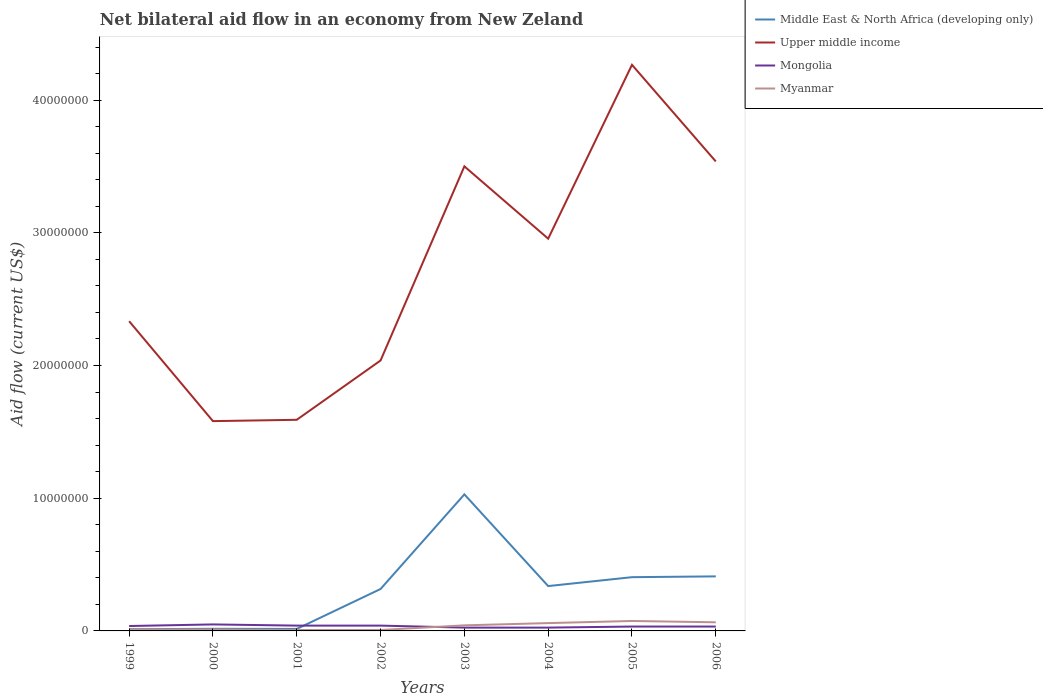How many different coloured lines are there?
Give a very brief answer. 4. Does the line corresponding to Myanmar intersect with the line corresponding to Middle East & North Africa (developing only)?
Keep it short and to the point. No. Across all years, what is the maximum net bilateral aid flow in Middle East & North Africa (developing only)?
Make the answer very short. 1.30e+05. In which year was the net bilateral aid flow in Myanmar maximum?
Give a very brief answer. 2001. What is the total net bilateral aid flow in Upper middle income in the graph?
Offer a very short reply. -4.57e+06. What is the difference between the highest and the second highest net bilateral aid flow in Upper middle income?
Your answer should be compact. 2.68e+07. Is the net bilateral aid flow in Upper middle income strictly greater than the net bilateral aid flow in Middle East & North Africa (developing only) over the years?
Ensure brevity in your answer.  No. How many lines are there?
Offer a terse response. 4. What is the difference between two consecutive major ticks on the Y-axis?
Your answer should be very brief. 1.00e+07. Are the values on the major ticks of Y-axis written in scientific E-notation?
Offer a very short reply. No. Does the graph contain any zero values?
Your answer should be very brief. No. Where does the legend appear in the graph?
Provide a short and direct response. Top right. How many legend labels are there?
Provide a short and direct response. 4. How are the legend labels stacked?
Provide a succinct answer. Vertical. What is the title of the graph?
Your answer should be very brief. Net bilateral aid flow in an economy from New Zeland. Does "Saudi Arabia" appear as one of the legend labels in the graph?
Your answer should be very brief. No. What is the label or title of the X-axis?
Make the answer very short. Years. What is the Aid flow (current US$) in Upper middle income in 1999?
Your answer should be very brief. 2.33e+07. What is the Aid flow (current US$) in Myanmar in 1999?
Your answer should be compact. 1.10e+05. What is the Aid flow (current US$) in Middle East & North Africa (developing only) in 2000?
Keep it short and to the point. 1.60e+05. What is the Aid flow (current US$) in Upper middle income in 2000?
Your answer should be very brief. 1.58e+07. What is the Aid flow (current US$) of Middle East & North Africa (developing only) in 2001?
Make the answer very short. 1.50e+05. What is the Aid flow (current US$) in Upper middle income in 2001?
Provide a succinct answer. 1.59e+07. What is the Aid flow (current US$) of Myanmar in 2001?
Your answer should be compact. 7.00e+04. What is the Aid flow (current US$) of Middle East & North Africa (developing only) in 2002?
Make the answer very short. 3.16e+06. What is the Aid flow (current US$) in Upper middle income in 2002?
Give a very brief answer. 2.04e+07. What is the Aid flow (current US$) in Mongolia in 2002?
Your answer should be very brief. 4.00e+05. What is the Aid flow (current US$) of Middle East & North Africa (developing only) in 2003?
Offer a terse response. 1.03e+07. What is the Aid flow (current US$) in Upper middle income in 2003?
Offer a very short reply. 3.50e+07. What is the Aid flow (current US$) of Myanmar in 2003?
Provide a succinct answer. 4.20e+05. What is the Aid flow (current US$) in Middle East & North Africa (developing only) in 2004?
Give a very brief answer. 3.38e+06. What is the Aid flow (current US$) of Upper middle income in 2004?
Offer a terse response. 2.96e+07. What is the Aid flow (current US$) of Mongolia in 2004?
Make the answer very short. 2.50e+05. What is the Aid flow (current US$) in Myanmar in 2004?
Give a very brief answer. 5.90e+05. What is the Aid flow (current US$) in Middle East & North Africa (developing only) in 2005?
Offer a terse response. 4.05e+06. What is the Aid flow (current US$) of Upper middle income in 2005?
Keep it short and to the point. 4.27e+07. What is the Aid flow (current US$) of Myanmar in 2005?
Provide a succinct answer. 7.50e+05. What is the Aid flow (current US$) of Middle East & North Africa (developing only) in 2006?
Your answer should be compact. 4.11e+06. What is the Aid flow (current US$) of Upper middle income in 2006?
Your answer should be compact. 3.54e+07. What is the Aid flow (current US$) of Mongolia in 2006?
Keep it short and to the point. 3.30e+05. What is the Aid flow (current US$) of Myanmar in 2006?
Ensure brevity in your answer.  6.50e+05. Across all years, what is the maximum Aid flow (current US$) in Middle East & North Africa (developing only)?
Make the answer very short. 1.03e+07. Across all years, what is the maximum Aid flow (current US$) in Upper middle income?
Offer a very short reply. 4.27e+07. Across all years, what is the maximum Aid flow (current US$) in Mongolia?
Your answer should be compact. 4.90e+05. Across all years, what is the maximum Aid flow (current US$) of Myanmar?
Keep it short and to the point. 7.50e+05. Across all years, what is the minimum Aid flow (current US$) in Middle East & North Africa (developing only)?
Offer a terse response. 1.30e+05. Across all years, what is the minimum Aid flow (current US$) of Upper middle income?
Ensure brevity in your answer.  1.58e+07. Across all years, what is the minimum Aid flow (current US$) of Mongolia?
Ensure brevity in your answer.  2.50e+05. Across all years, what is the minimum Aid flow (current US$) in Myanmar?
Your response must be concise. 7.00e+04. What is the total Aid flow (current US$) of Middle East & North Africa (developing only) in the graph?
Give a very brief answer. 2.54e+07. What is the total Aid flow (current US$) in Upper middle income in the graph?
Provide a succinct answer. 2.18e+08. What is the total Aid flow (current US$) of Mongolia in the graph?
Offer a terse response. 2.82e+06. What is the total Aid flow (current US$) of Myanmar in the graph?
Your response must be concise. 2.76e+06. What is the difference between the Aid flow (current US$) in Upper middle income in 1999 and that in 2000?
Give a very brief answer. 7.53e+06. What is the difference between the Aid flow (current US$) in Middle East & North Africa (developing only) in 1999 and that in 2001?
Ensure brevity in your answer.  -2.00e+04. What is the difference between the Aid flow (current US$) in Upper middle income in 1999 and that in 2001?
Keep it short and to the point. 7.43e+06. What is the difference between the Aid flow (current US$) of Mongolia in 1999 and that in 2001?
Give a very brief answer. -3.00e+04. What is the difference between the Aid flow (current US$) in Myanmar in 1999 and that in 2001?
Offer a terse response. 4.00e+04. What is the difference between the Aid flow (current US$) in Middle East & North Africa (developing only) in 1999 and that in 2002?
Your response must be concise. -3.03e+06. What is the difference between the Aid flow (current US$) of Upper middle income in 1999 and that in 2002?
Provide a succinct answer. 2.96e+06. What is the difference between the Aid flow (current US$) of Mongolia in 1999 and that in 2002?
Offer a very short reply. -3.00e+04. What is the difference between the Aid flow (current US$) in Myanmar in 1999 and that in 2002?
Give a very brief answer. 4.00e+04. What is the difference between the Aid flow (current US$) of Middle East & North Africa (developing only) in 1999 and that in 2003?
Give a very brief answer. -1.02e+07. What is the difference between the Aid flow (current US$) in Upper middle income in 1999 and that in 2003?
Ensure brevity in your answer.  -1.17e+07. What is the difference between the Aid flow (current US$) of Mongolia in 1999 and that in 2003?
Give a very brief answer. 1.20e+05. What is the difference between the Aid flow (current US$) in Myanmar in 1999 and that in 2003?
Your answer should be compact. -3.10e+05. What is the difference between the Aid flow (current US$) in Middle East & North Africa (developing only) in 1999 and that in 2004?
Give a very brief answer. -3.25e+06. What is the difference between the Aid flow (current US$) in Upper middle income in 1999 and that in 2004?
Provide a succinct answer. -6.22e+06. What is the difference between the Aid flow (current US$) in Mongolia in 1999 and that in 2004?
Your answer should be compact. 1.20e+05. What is the difference between the Aid flow (current US$) in Myanmar in 1999 and that in 2004?
Ensure brevity in your answer.  -4.80e+05. What is the difference between the Aid flow (current US$) in Middle East & North Africa (developing only) in 1999 and that in 2005?
Your response must be concise. -3.92e+06. What is the difference between the Aid flow (current US$) of Upper middle income in 1999 and that in 2005?
Your answer should be compact. -1.93e+07. What is the difference between the Aid flow (current US$) in Myanmar in 1999 and that in 2005?
Provide a succinct answer. -6.40e+05. What is the difference between the Aid flow (current US$) of Middle East & North Africa (developing only) in 1999 and that in 2006?
Keep it short and to the point. -3.98e+06. What is the difference between the Aid flow (current US$) of Upper middle income in 1999 and that in 2006?
Ensure brevity in your answer.  -1.20e+07. What is the difference between the Aid flow (current US$) in Mongolia in 1999 and that in 2006?
Offer a terse response. 4.00e+04. What is the difference between the Aid flow (current US$) in Myanmar in 1999 and that in 2006?
Keep it short and to the point. -5.40e+05. What is the difference between the Aid flow (current US$) in Middle East & North Africa (developing only) in 2000 and that in 2001?
Ensure brevity in your answer.  10000. What is the difference between the Aid flow (current US$) of Middle East & North Africa (developing only) in 2000 and that in 2002?
Offer a very short reply. -3.00e+06. What is the difference between the Aid flow (current US$) of Upper middle income in 2000 and that in 2002?
Your response must be concise. -4.57e+06. What is the difference between the Aid flow (current US$) in Mongolia in 2000 and that in 2002?
Provide a short and direct response. 9.00e+04. What is the difference between the Aid flow (current US$) in Myanmar in 2000 and that in 2002?
Give a very brief answer. 3.00e+04. What is the difference between the Aid flow (current US$) of Middle East & North Africa (developing only) in 2000 and that in 2003?
Give a very brief answer. -1.01e+07. What is the difference between the Aid flow (current US$) of Upper middle income in 2000 and that in 2003?
Provide a succinct answer. -1.92e+07. What is the difference between the Aid flow (current US$) in Myanmar in 2000 and that in 2003?
Offer a terse response. -3.20e+05. What is the difference between the Aid flow (current US$) of Middle East & North Africa (developing only) in 2000 and that in 2004?
Your answer should be compact. -3.22e+06. What is the difference between the Aid flow (current US$) in Upper middle income in 2000 and that in 2004?
Offer a terse response. -1.38e+07. What is the difference between the Aid flow (current US$) of Myanmar in 2000 and that in 2004?
Give a very brief answer. -4.90e+05. What is the difference between the Aid flow (current US$) of Middle East & North Africa (developing only) in 2000 and that in 2005?
Your answer should be very brief. -3.89e+06. What is the difference between the Aid flow (current US$) of Upper middle income in 2000 and that in 2005?
Keep it short and to the point. -2.68e+07. What is the difference between the Aid flow (current US$) of Mongolia in 2000 and that in 2005?
Offer a terse response. 1.60e+05. What is the difference between the Aid flow (current US$) of Myanmar in 2000 and that in 2005?
Ensure brevity in your answer.  -6.50e+05. What is the difference between the Aid flow (current US$) in Middle East & North Africa (developing only) in 2000 and that in 2006?
Make the answer very short. -3.95e+06. What is the difference between the Aid flow (current US$) in Upper middle income in 2000 and that in 2006?
Your answer should be very brief. -1.96e+07. What is the difference between the Aid flow (current US$) in Myanmar in 2000 and that in 2006?
Ensure brevity in your answer.  -5.50e+05. What is the difference between the Aid flow (current US$) of Middle East & North Africa (developing only) in 2001 and that in 2002?
Provide a short and direct response. -3.01e+06. What is the difference between the Aid flow (current US$) in Upper middle income in 2001 and that in 2002?
Provide a succinct answer. -4.47e+06. What is the difference between the Aid flow (current US$) in Mongolia in 2001 and that in 2002?
Your answer should be very brief. 0. What is the difference between the Aid flow (current US$) in Myanmar in 2001 and that in 2002?
Your response must be concise. 0. What is the difference between the Aid flow (current US$) of Middle East & North Africa (developing only) in 2001 and that in 2003?
Your answer should be very brief. -1.01e+07. What is the difference between the Aid flow (current US$) of Upper middle income in 2001 and that in 2003?
Your response must be concise. -1.91e+07. What is the difference between the Aid flow (current US$) of Mongolia in 2001 and that in 2003?
Offer a terse response. 1.50e+05. What is the difference between the Aid flow (current US$) in Myanmar in 2001 and that in 2003?
Provide a succinct answer. -3.50e+05. What is the difference between the Aid flow (current US$) of Middle East & North Africa (developing only) in 2001 and that in 2004?
Provide a succinct answer. -3.23e+06. What is the difference between the Aid flow (current US$) in Upper middle income in 2001 and that in 2004?
Make the answer very short. -1.36e+07. What is the difference between the Aid flow (current US$) in Myanmar in 2001 and that in 2004?
Offer a terse response. -5.20e+05. What is the difference between the Aid flow (current US$) in Middle East & North Africa (developing only) in 2001 and that in 2005?
Keep it short and to the point. -3.90e+06. What is the difference between the Aid flow (current US$) in Upper middle income in 2001 and that in 2005?
Keep it short and to the point. -2.68e+07. What is the difference between the Aid flow (current US$) in Myanmar in 2001 and that in 2005?
Offer a very short reply. -6.80e+05. What is the difference between the Aid flow (current US$) in Middle East & North Africa (developing only) in 2001 and that in 2006?
Your response must be concise. -3.96e+06. What is the difference between the Aid flow (current US$) of Upper middle income in 2001 and that in 2006?
Offer a terse response. -1.95e+07. What is the difference between the Aid flow (current US$) in Myanmar in 2001 and that in 2006?
Ensure brevity in your answer.  -5.80e+05. What is the difference between the Aid flow (current US$) of Middle East & North Africa (developing only) in 2002 and that in 2003?
Offer a terse response. -7.13e+06. What is the difference between the Aid flow (current US$) in Upper middle income in 2002 and that in 2003?
Keep it short and to the point. -1.46e+07. What is the difference between the Aid flow (current US$) of Mongolia in 2002 and that in 2003?
Ensure brevity in your answer.  1.50e+05. What is the difference between the Aid flow (current US$) in Myanmar in 2002 and that in 2003?
Offer a very short reply. -3.50e+05. What is the difference between the Aid flow (current US$) of Middle East & North Africa (developing only) in 2002 and that in 2004?
Offer a terse response. -2.20e+05. What is the difference between the Aid flow (current US$) of Upper middle income in 2002 and that in 2004?
Keep it short and to the point. -9.18e+06. What is the difference between the Aid flow (current US$) in Mongolia in 2002 and that in 2004?
Provide a succinct answer. 1.50e+05. What is the difference between the Aid flow (current US$) in Myanmar in 2002 and that in 2004?
Your response must be concise. -5.20e+05. What is the difference between the Aid flow (current US$) in Middle East & North Africa (developing only) in 2002 and that in 2005?
Provide a succinct answer. -8.90e+05. What is the difference between the Aid flow (current US$) of Upper middle income in 2002 and that in 2005?
Your answer should be very brief. -2.23e+07. What is the difference between the Aid flow (current US$) of Myanmar in 2002 and that in 2005?
Offer a terse response. -6.80e+05. What is the difference between the Aid flow (current US$) of Middle East & North Africa (developing only) in 2002 and that in 2006?
Provide a short and direct response. -9.50e+05. What is the difference between the Aid flow (current US$) in Upper middle income in 2002 and that in 2006?
Make the answer very short. -1.50e+07. What is the difference between the Aid flow (current US$) in Myanmar in 2002 and that in 2006?
Make the answer very short. -5.80e+05. What is the difference between the Aid flow (current US$) in Middle East & North Africa (developing only) in 2003 and that in 2004?
Your answer should be very brief. 6.91e+06. What is the difference between the Aid flow (current US$) in Upper middle income in 2003 and that in 2004?
Provide a succinct answer. 5.45e+06. What is the difference between the Aid flow (current US$) in Myanmar in 2003 and that in 2004?
Your answer should be very brief. -1.70e+05. What is the difference between the Aid flow (current US$) in Middle East & North Africa (developing only) in 2003 and that in 2005?
Give a very brief answer. 6.24e+06. What is the difference between the Aid flow (current US$) in Upper middle income in 2003 and that in 2005?
Ensure brevity in your answer.  -7.65e+06. What is the difference between the Aid flow (current US$) in Myanmar in 2003 and that in 2005?
Your response must be concise. -3.30e+05. What is the difference between the Aid flow (current US$) in Middle East & North Africa (developing only) in 2003 and that in 2006?
Keep it short and to the point. 6.18e+06. What is the difference between the Aid flow (current US$) in Upper middle income in 2003 and that in 2006?
Your answer should be compact. -3.70e+05. What is the difference between the Aid flow (current US$) in Middle East & North Africa (developing only) in 2004 and that in 2005?
Make the answer very short. -6.70e+05. What is the difference between the Aid flow (current US$) in Upper middle income in 2004 and that in 2005?
Your answer should be very brief. -1.31e+07. What is the difference between the Aid flow (current US$) of Mongolia in 2004 and that in 2005?
Your answer should be very brief. -8.00e+04. What is the difference between the Aid flow (current US$) of Middle East & North Africa (developing only) in 2004 and that in 2006?
Provide a short and direct response. -7.30e+05. What is the difference between the Aid flow (current US$) in Upper middle income in 2004 and that in 2006?
Offer a very short reply. -5.82e+06. What is the difference between the Aid flow (current US$) in Mongolia in 2004 and that in 2006?
Offer a terse response. -8.00e+04. What is the difference between the Aid flow (current US$) in Upper middle income in 2005 and that in 2006?
Ensure brevity in your answer.  7.28e+06. What is the difference between the Aid flow (current US$) of Middle East & North Africa (developing only) in 1999 and the Aid flow (current US$) of Upper middle income in 2000?
Your answer should be very brief. -1.57e+07. What is the difference between the Aid flow (current US$) in Middle East & North Africa (developing only) in 1999 and the Aid flow (current US$) in Mongolia in 2000?
Ensure brevity in your answer.  -3.60e+05. What is the difference between the Aid flow (current US$) in Middle East & North Africa (developing only) in 1999 and the Aid flow (current US$) in Myanmar in 2000?
Your answer should be very brief. 3.00e+04. What is the difference between the Aid flow (current US$) of Upper middle income in 1999 and the Aid flow (current US$) of Mongolia in 2000?
Your answer should be compact. 2.28e+07. What is the difference between the Aid flow (current US$) in Upper middle income in 1999 and the Aid flow (current US$) in Myanmar in 2000?
Your answer should be very brief. 2.32e+07. What is the difference between the Aid flow (current US$) in Mongolia in 1999 and the Aid flow (current US$) in Myanmar in 2000?
Offer a terse response. 2.70e+05. What is the difference between the Aid flow (current US$) in Middle East & North Africa (developing only) in 1999 and the Aid flow (current US$) in Upper middle income in 2001?
Give a very brief answer. -1.58e+07. What is the difference between the Aid flow (current US$) in Middle East & North Africa (developing only) in 1999 and the Aid flow (current US$) in Myanmar in 2001?
Your answer should be very brief. 6.00e+04. What is the difference between the Aid flow (current US$) of Upper middle income in 1999 and the Aid flow (current US$) of Mongolia in 2001?
Give a very brief answer. 2.29e+07. What is the difference between the Aid flow (current US$) in Upper middle income in 1999 and the Aid flow (current US$) in Myanmar in 2001?
Keep it short and to the point. 2.33e+07. What is the difference between the Aid flow (current US$) of Mongolia in 1999 and the Aid flow (current US$) of Myanmar in 2001?
Your answer should be compact. 3.00e+05. What is the difference between the Aid flow (current US$) of Middle East & North Africa (developing only) in 1999 and the Aid flow (current US$) of Upper middle income in 2002?
Your answer should be compact. -2.02e+07. What is the difference between the Aid flow (current US$) in Middle East & North Africa (developing only) in 1999 and the Aid flow (current US$) in Mongolia in 2002?
Provide a succinct answer. -2.70e+05. What is the difference between the Aid flow (current US$) of Middle East & North Africa (developing only) in 1999 and the Aid flow (current US$) of Myanmar in 2002?
Keep it short and to the point. 6.00e+04. What is the difference between the Aid flow (current US$) of Upper middle income in 1999 and the Aid flow (current US$) of Mongolia in 2002?
Your answer should be very brief. 2.29e+07. What is the difference between the Aid flow (current US$) of Upper middle income in 1999 and the Aid flow (current US$) of Myanmar in 2002?
Your answer should be very brief. 2.33e+07. What is the difference between the Aid flow (current US$) in Mongolia in 1999 and the Aid flow (current US$) in Myanmar in 2002?
Give a very brief answer. 3.00e+05. What is the difference between the Aid flow (current US$) in Middle East & North Africa (developing only) in 1999 and the Aid flow (current US$) in Upper middle income in 2003?
Give a very brief answer. -3.49e+07. What is the difference between the Aid flow (current US$) in Middle East & North Africa (developing only) in 1999 and the Aid flow (current US$) in Mongolia in 2003?
Keep it short and to the point. -1.20e+05. What is the difference between the Aid flow (current US$) of Upper middle income in 1999 and the Aid flow (current US$) of Mongolia in 2003?
Make the answer very short. 2.31e+07. What is the difference between the Aid flow (current US$) of Upper middle income in 1999 and the Aid flow (current US$) of Myanmar in 2003?
Provide a short and direct response. 2.29e+07. What is the difference between the Aid flow (current US$) in Mongolia in 1999 and the Aid flow (current US$) in Myanmar in 2003?
Provide a short and direct response. -5.00e+04. What is the difference between the Aid flow (current US$) in Middle East & North Africa (developing only) in 1999 and the Aid flow (current US$) in Upper middle income in 2004?
Offer a very short reply. -2.94e+07. What is the difference between the Aid flow (current US$) of Middle East & North Africa (developing only) in 1999 and the Aid flow (current US$) of Myanmar in 2004?
Give a very brief answer. -4.60e+05. What is the difference between the Aid flow (current US$) of Upper middle income in 1999 and the Aid flow (current US$) of Mongolia in 2004?
Offer a terse response. 2.31e+07. What is the difference between the Aid flow (current US$) in Upper middle income in 1999 and the Aid flow (current US$) in Myanmar in 2004?
Your answer should be very brief. 2.28e+07. What is the difference between the Aid flow (current US$) in Mongolia in 1999 and the Aid flow (current US$) in Myanmar in 2004?
Offer a terse response. -2.20e+05. What is the difference between the Aid flow (current US$) of Middle East & North Africa (developing only) in 1999 and the Aid flow (current US$) of Upper middle income in 2005?
Your answer should be compact. -4.25e+07. What is the difference between the Aid flow (current US$) in Middle East & North Africa (developing only) in 1999 and the Aid flow (current US$) in Myanmar in 2005?
Offer a very short reply. -6.20e+05. What is the difference between the Aid flow (current US$) of Upper middle income in 1999 and the Aid flow (current US$) of Mongolia in 2005?
Offer a very short reply. 2.30e+07. What is the difference between the Aid flow (current US$) of Upper middle income in 1999 and the Aid flow (current US$) of Myanmar in 2005?
Keep it short and to the point. 2.26e+07. What is the difference between the Aid flow (current US$) of Mongolia in 1999 and the Aid flow (current US$) of Myanmar in 2005?
Offer a very short reply. -3.80e+05. What is the difference between the Aid flow (current US$) of Middle East & North Africa (developing only) in 1999 and the Aid flow (current US$) of Upper middle income in 2006?
Your response must be concise. -3.52e+07. What is the difference between the Aid flow (current US$) of Middle East & North Africa (developing only) in 1999 and the Aid flow (current US$) of Myanmar in 2006?
Your answer should be very brief. -5.20e+05. What is the difference between the Aid flow (current US$) in Upper middle income in 1999 and the Aid flow (current US$) in Mongolia in 2006?
Provide a short and direct response. 2.30e+07. What is the difference between the Aid flow (current US$) in Upper middle income in 1999 and the Aid flow (current US$) in Myanmar in 2006?
Offer a very short reply. 2.27e+07. What is the difference between the Aid flow (current US$) in Mongolia in 1999 and the Aid flow (current US$) in Myanmar in 2006?
Your answer should be compact. -2.80e+05. What is the difference between the Aid flow (current US$) in Middle East & North Africa (developing only) in 2000 and the Aid flow (current US$) in Upper middle income in 2001?
Offer a terse response. -1.58e+07. What is the difference between the Aid flow (current US$) in Middle East & North Africa (developing only) in 2000 and the Aid flow (current US$) in Mongolia in 2001?
Your answer should be compact. -2.40e+05. What is the difference between the Aid flow (current US$) in Middle East & North Africa (developing only) in 2000 and the Aid flow (current US$) in Myanmar in 2001?
Offer a very short reply. 9.00e+04. What is the difference between the Aid flow (current US$) of Upper middle income in 2000 and the Aid flow (current US$) of Mongolia in 2001?
Offer a very short reply. 1.54e+07. What is the difference between the Aid flow (current US$) of Upper middle income in 2000 and the Aid flow (current US$) of Myanmar in 2001?
Make the answer very short. 1.57e+07. What is the difference between the Aid flow (current US$) of Middle East & North Africa (developing only) in 2000 and the Aid flow (current US$) of Upper middle income in 2002?
Provide a short and direct response. -2.02e+07. What is the difference between the Aid flow (current US$) of Upper middle income in 2000 and the Aid flow (current US$) of Mongolia in 2002?
Offer a terse response. 1.54e+07. What is the difference between the Aid flow (current US$) of Upper middle income in 2000 and the Aid flow (current US$) of Myanmar in 2002?
Your response must be concise. 1.57e+07. What is the difference between the Aid flow (current US$) in Mongolia in 2000 and the Aid flow (current US$) in Myanmar in 2002?
Offer a terse response. 4.20e+05. What is the difference between the Aid flow (current US$) of Middle East & North Africa (developing only) in 2000 and the Aid flow (current US$) of Upper middle income in 2003?
Offer a very short reply. -3.48e+07. What is the difference between the Aid flow (current US$) of Middle East & North Africa (developing only) in 2000 and the Aid flow (current US$) of Mongolia in 2003?
Provide a succinct answer. -9.00e+04. What is the difference between the Aid flow (current US$) of Middle East & North Africa (developing only) in 2000 and the Aid flow (current US$) of Myanmar in 2003?
Offer a terse response. -2.60e+05. What is the difference between the Aid flow (current US$) of Upper middle income in 2000 and the Aid flow (current US$) of Mongolia in 2003?
Your response must be concise. 1.56e+07. What is the difference between the Aid flow (current US$) of Upper middle income in 2000 and the Aid flow (current US$) of Myanmar in 2003?
Your answer should be compact. 1.54e+07. What is the difference between the Aid flow (current US$) in Mongolia in 2000 and the Aid flow (current US$) in Myanmar in 2003?
Offer a terse response. 7.00e+04. What is the difference between the Aid flow (current US$) in Middle East & North Africa (developing only) in 2000 and the Aid flow (current US$) in Upper middle income in 2004?
Your response must be concise. -2.94e+07. What is the difference between the Aid flow (current US$) in Middle East & North Africa (developing only) in 2000 and the Aid flow (current US$) in Myanmar in 2004?
Give a very brief answer. -4.30e+05. What is the difference between the Aid flow (current US$) of Upper middle income in 2000 and the Aid flow (current US$) of Mongolia in 2004?
Make the answer very short. 1.56e+07. What is the difference between the Aid flow (current US$) in Upper middle income in 2000 and the Aid flow (current US$) in Myanmar in 2004?
Offer a very short reply. 1.52e+07. What is the difference between the Aid flow (current US$) in Middle East & North Africa (developing only) in 2000 and the Aid flow (current US$) in Upper middle income in 2005?
Keep it short and to the point. -4.25e+07. What is the difference between the Aid flow (current US$) in Middle East & North Africa (developing only) in 2000 and the Aid flow (current US$) in Myanmar in 2005?
Your response must be concise. -5.90e+05. What is the difference between the Aid flow (current US$) in Upper middle income in 2000 and the Aid flow (current US$) in Mongolia in 2005?
Make the answer very short. 1.55e+07. What is the difference between the Aid flow (current US$) of Upper middle income in 2000 and the Aid flow (current US$) of Myanmar in 2005?
Offer a very short reply. 1.51e+07. What is the difference between the Aid flow (current US$) in Middle East & North Africa (developing only) in 2000 and the Aid flow (current US$) in Upper middle income in 2006?
Provide a succinct answer. -3.52e+07. What is the difference between the Aid flow (current US$) of Middle East & North Africa (developing only) in 2000 and the Aid flow (current US$) of Mongolia in 2006?
Your response must be concise. -1.70e+05. What is the difference between the Aid flow (current US$) in Middle East & North Africa (developing only) in 2000 and the Aid flow (current US$) in Myanmar in 2006?
Keep it short and to the point. -4.90e+05. What is the difference between the Aid flow (current US$) of Upper middle income in 2000 and the Aid flow (current US$) of Mongolia in 2006?
Provide a short and direct response. 1.55e+07. What is the difference between the Aid flow (current US$) of Upper middle income in 2000 and the Aid flow (current US$) of Myanmar in 2006?
Your response must be concise. 1.52e+07. What is the difference between the Aid flow (current US$) in Middle East & North Africa (developing only) in 2001 and the Aid flow (current US$) in Upper middle income in 2002?
Give a very brief answer. -2.02e+07. What is the difference between the Aid flow (current US$) in Middle East & North Africa (developing only) in 2001 and the Aid flow (current US$) in Mongolia in 2002?
Provide a short and direct response. -2.50e+05. What is the difference between the Aid flow (current US$) in Upper middle income in 2001 and the Aid flow (current US$) in Mongolia in 2002?
Give a very brief answer. 1.55e+07. What is the difference between the Aid flow (current US$) of Upper middle income in 2001 and the Aid flow (current US$) of Myanmar in 2002?
Your response must be concise. 1.58e+07. What is the difference between the Aid flow (current US$) in Mongolia in 2001 and the Aid flow (current US$) in Myanmar in 2002?
Give a very brief answer. 3.30e+05. What is the difference between the Aid flow (current US$) of Middle East & North Africa (developing only) in 2001 and the Aid flow (current US$) of Upper middle income in 2003?
Your answer should be very brief. -3.49e+07. What is the difference between the Aid flow (current US$) in Upper middle income in 2001 and the Aid flow (current US$) in Mongolia in 2003?
Provide a short and direct response. 1.57e+07. What is the difference between the Aid flow (current US$) of Upper middle income in 2001 and the Aid flow (current US$) of Myanmar in 2003?
Provide a succinct answer. 1.55e+07. What is the difference between the Aid flow (current US$) of Mongolia in 2001 and the Aid flow (current US$) of Myanmar in 2003?
Make the answer very short. -2.00e+04. What is the difference between the Aid flow (current US$) of Middle East & North Africa (developing only) in 2001 and the Aid flow (current US$) of Upper middle income in 2004?
Provide a short and direct response. -2.94e+07. What is the difference between the Aid flow (current US$) of Middle East & North Africa (developing only) in 2001 and the Aid flow (current US$) of Mongolia in 2004?
Provide a succinct answer. -1.00e+05. What is the difference between the Aid flow (current US$) in Middle East & North Africa (developing only) in 2001 and the Aid flow (current US$) in Myanmar in 2004?
Make the answer very short. -4.40e+05. What is the difference between the Aid flow (current US$) of Upper middle income in 2001 and the Aid flow (current US$) of Mongolia in 2004?
Make the answer very short. 1.57e+07. What is the difference between the Aid flow (current US$) in Upper middle income in 2001 and the Aid flow (current US$) in Myanmar in 2004?
Your answer should be very brief. 1.53e+07. What is the difference between the Aid flow (current US$) of Middle East & North Africa (developing only) in 2001 and the Aid flow (current US$) of Upper middle income in 2005?
Keep it short and to the point. -4.25e+07. What is the difference between the Aid flow (current US$) of Middle East & North Africa (developing only) in 2001 and the Aid flow (current US$) of Mongolia in 2005?
Keep it short and to the point. -1.80e+05. What is the difference between the Aid flow (current US$) in Middle East & North Africa (developing only) in 2001 and the Aid flow (current US$) in Myanmar in 2005?
Offer a terse response. -6.00e+05. What is the difference between the Aid flow (current US$) of Upper middle income in 2001 and the Aid flow (current US$) of Mongolia in 2005?
Your response must be concise. 1.56e+07. What is the difference between the Aid flow (current US$) in Upper middle income in 2001 and the Aid flow (current US$) in Myanmar in 2005?
Give a very brief answer. 1.52e+07. What is the difference between the Aid flow (current US$) of Mongolia in 2001 and the Aid flow (current US$) of Myanmar in 2005?
Keep it short and to the point. -3.50e+05. What is the difference between the Aid flow (current US$) in Middle East & North Africa (developing only) in 2001 and the Aid flow (current US$) in Upper middle income in 2006?
Provide a short and direct response. -3.52e+07. What is the difference between the Aid flow (current US$) of Middle East & North Africa (developing only) in 2001 and the Aid flow (current US$) of Mongolia in 2006?
Ensure brevity in your answer.  -1.80e+05. What is the difference between the Aid flow (current US$) in Middle East & North Africa (developing only) in 2001 and the Aid flow (current US$) in Myanmar in 2006?
Ensure brevity in your answer.  -5.00e+05. What is the difference between the Aid flow (current US$) in Upper middle income in 2001 and the Aid flow (current US$) in Mongolia in 2006?
Provide a short and direct response. 1.56e+07. What is the difference between the Aid flow (current US$) in Upper middle income in 2001 and the Aid flow (current US$) in Myanmar in 2006?
Keep it short and to the point. 1.53e+07. What is the difference between the Aid flow (current US$) in Middle East & North Africa (developing only) in 2002 and the Aid flow (current US$) in Upper middle income in 2003?
Provide a short and direct response. -3.18e+07. What is the difference between the Aid flow (current US$) in Middle East & North Africa (developing only) in 2002 and the Aid flow (current US$) in Mongolia in 2003?
Offer a terse response. 2.91e+06. What is the difference between the Aid flow (current US$) of Middle East & North Africa (developing only) in 2002 and the Aid flow (current US$) of Myanmar in 2003?
Ensure brevity in your answer.  2.74e+06. What is the difference between the Aid flow (current US$) in Upper middle income in 2002 and the Aid flow (current US$) in Mongolia in 2003?
Provide a short and direct response. 2.01e+07. What is the difference between the Aid flow (current US$) of Upper middle income in 2002 and the Aid flow (current US$) of Myanmar in 2003?
Make the answer very short. 2.00e+07. What is the difference between the Aid flow (current US$) in Middle East & North Africa (developing only) in 2002 and the Aid flow (current US$) in Upper middle income in 2004?
Your answer should be very brief. -2.64e+07. What is the difference between the Aid flow (current US$) in Middle East & North Africa (developing only) in 2002 and the Aid flow (current US$) in Mongolia in 2004?
Provide a succinct answer. 2.91e+06. What is the difference between the Aid flow (current US$) in Middle East & North Africa (developing only) in 2002 and the Aid flow (current US$) in Myanmar in 2004?
Offer a terse response. 2.57e+06. What is the difference between the Aid flow (current US$) in Upper middle income in 2002 and the Aid flow (current US$) in Mongolia in 2004?
Your response must be concise. 2.01e+07. What is the difference between the Aid flow (current US$) of Upper middle income in 2002 and the Aid flow (current US$) of Myanmar in 2004?
Your response must be concise. 1.98e+07. What is the difference between the Aid flow (current US$) in Middle East & North Africa (developing only) in 2002 and the Aid flow (current US$) in Upper middle income in 2005?
Ensure brevity in your answer.  -3.95e+07. What is the difference between the Aid flow (current US$) in Middle East & North Africa (developing only) in 2002 and the Aid flow (current US$) in Mongolia in 2005?
Keep it short and to the point. 2.83e+06. What is the difference between the Aid flow (current US$) in Middle East & North Africa (developing only) in 2002 and the Aid flow (current US$) in Myanmar in 2005?
Your answer should be very brief. 2.41e+06. What is the difference between the Aid flow (current US$) of Upper middle income in 2002 and the Aid flow (current US$) of Mongolia in 2005?
Provide a succinct answer. 2.00e+07. What is the difference between the Aid flow (current US$) of Upper middle income in 2002 and the Aid flow (current US$) of Myanmar in 2005?
Give a very brief answer. 1.96e+07. What is the difference between the Aid flow (current US$) of Mongolia in 2002 and the Aid flow (current US$) of Myanmar in 2005?
Offer a very short reply. -3.50e+05. What is the difference between the Aid flow (current US$) in Middle East & North Africa (developing only) in 2002 and the Aid flow (current US$) in Upper middle income in 2006?
Your answer should be very brief. -3.22e+07. What is the difference between the Aid flow (current US$) in Middle East & North Africa (developing only) in 2002 and the Aid flow (current US$) in Mongolia in 2006?
Make the answer very short. 2.83e+06. What is the difference between the Aid flow (current US$) in Middle East & North Africa (developing only) in 2002 and the Aid flow (current US$) in Myanmar in 2006?
Provide a succinct answer. 2.51e+06. What is the difference between the Aid flow (current US$) of Upper middle income in 2002 and the Aid flow (current US$) of Mongolia in 2006?
Offer a very short reply. 2.00e+07. What is the difference between the Aid flow (current US$) in Upper middle income in 2002 and the Aid flow (current US$) in Myanmar in 2006?
Ensure brevity in your answer.  1.97e+07. What is the difference between the Aid flow (current US$) of Mongolia in 2002 and the Aid flow (current US$) of Myanmar in 2006?
Make the answer very short. -2.50e+05. What is the difference between the Aid flow (current US$) in Middle East & North Africa (developing only) in 2003 and the Aid flow (current US$) in Upper middle income in 2004?
Your answer should be very brief. -1.93e+07. What is the difference between the Aid flow (current US$) of Middle East & North Africa (developing only) in 2003 and the Aid flow (current US$) of Mongolia in 2004?
Offer a very short reply. 1.00e+07. What is the difference between the Aid flow (current US$) of Middle East & North Africa (developing only) in 2003 and the Aid flow (current US$) of Myanmar in 2004?
Your answer should be compact. 9.70e+06. What is the difference between the Aid flow (current US$) of Upper middle income in 2003 and the Aid flow (current US$) of Mongolia in 2004?
Make the answer very short. 3.48e+07. What is the difference between the Aid flow (current US$) in Upper middle income in 2003 and the Aid flow (current US$) in Myanmar in 2004?
Ensure brevity in your answer.  3.44e+07. What is the difference between the Aid flow (current US$) of Mongolia in 2003 and the Aid flow (current US$) of Myanmar in 2004?
Your answer should be compact. -3.40e+05. What is the difference between the Aid flow (current US$) in Middle East & North Africa (developing only) in 2003 and the Aid flow (current US$) in Upper middle income in 2005?
Your answer should be very brief. -3.24e+07. What is the difference between the Aid flow (current US$) of Middle East & North Africa (developing only) in 2003 and the Aid flow (current US$) of Mongolia in 2005?
Provide a short and direct response. 9.96e+06. What is the difference between the Aid flow (current US$) in Middle East & North Africa (developing only) in 2003 and the Aid flow (current US$) in Myanmar in 2005?
Your answer should be compact. 9.54e+06. What is the difference between the Aid flow (current US$) of Upper middle income in 2003 and the Aid flow (current US$) of Mongolia in 2005?
Your answer should be compact. 3.47e+07. What is the difference between the Aid flow (current US$) in Upper middle income in 2003 and the Aid flow (current US$) in Myanmar in 2005?
Offer a very short reply. 3.43e+07. What is the difference between the Aid flow (current US$) in Mongolia in 2003 and the Aid flow (current US$) in Myanmar in 2005?
Give a very brief answer. -5.00e+05. What is the difference between the Aid flow (current US$) in Middle East & North Africa (developing only) in 2003 and the Aid flow (current US$) in Upper middle income in 2006?
Provide a short and direct response. -2.51e+07. What is the difference between the Aid flow (current US$) of Middle East & North Africa (developing only) in 2003 and the Aid flow (current US$) of Mongolia in 2006?
Keep it short and to the point. 9.96e+06. What is the difference between the Aid flow (current US$) of Middle East & North Africa (developing only) in 2003 and the Aid flow (current US$) of Myanmar in 2006?
Ensure brevity in your answer.  9.64e+06. What is the difference between the Aid flow (current US$) in Upper middle income in 2003 and the Aid flow (current US$) in Mongolia in 2006?
Give a very brief answer. 3.47e+07. What is the difference between the Aid flow (current US$) of Upper middle income in 2003 and the Aid flow (current US$) of Myanmar in 2006?
Offer a very short reply. 3.44e+07. What is the difference between the Aid flow (current US$) in Mongolia in 2003 and the Aid flow (current US$) in Myanmar in 2006?
Ensure brevity in your answer.  -4.00e+05. What is the difference between the Aid flow (current US$) in Middle East & North Africa (developing only) in 2004 and the Aid flow (current US$) in Upper middle income in 2005?
Provide a short and direct response. -3.93e+07. What is the difference between the Aid flow (current US$) of Middle East & North Africa (developing only) in 2004 and the Aid flow (current US$) of Mongolia in 2005?
Provide a succinct answer. 3.05e+06. What is the difference between the Aid flow (current US$) in Middle East & North Africa (developing only) in 2004 and the Aid flow (current US$) in Myanmar in 2005?
Offer a very short reply. 2.63e+06. What is the difference between the Aid flow (current US$) in Upper middle income in 2004 and the Aid flow (current US$) in Mongolia in 2005?
Offer a very short reply. 2.92e+07. What is the difference between the Aid flow (current US$) of Upper middle income in 2004 and the Aid flow (current US$) of Myanmar in 2005?
Provide a succinct answer. 2.88e+07. What is the difference between the Aid flow (current US$) of Mongolia in 2004 and the Aid flow (current US$) of Myanmar in 2005?
Your answer should be compact. -5.00e+05. What is the difference between the Aid flow (current US$) in Middle East & North Africa (developing only) in 2004 and the Aid flow (current US$) in Upper middle income in 2006?
Your answer should be compact. -3.20e+07. What is the difference between the Aid flow (current US$) of Middle East & North Africa (developing only) in 2004 and the Aid flow (current US$) of Mongolia in 2006?
Give a very brief answer. 3.05e+06. What is the difference between the Aid flow (current US$) of Middle East & North Africa (developing only) in 2004 and the Aid flow (current US$) of Myanmar in 2006?
Your answer should be very brief. 2.73e+06. What is the difference between the Aid flow (current US$) of Upper middle income in 2004 and the Aid flow (current US$) of Mongolia in 2006?
Your answer should be compact. 2.92e+07. What is the difference between the Aid flow (current US$) of Upper middle income in 2004 and the Aid flow (current US$) of Myanmar in 2006?
Your answer should be compact. 2.89e+07. What is the difference between the Aid flow (current US$) of Mongolia in 2004 and the Aid flow (current US$) of Myanmar in 2006?
Ensure brevity in your answer.  -4.00e+05. What is the difference between the Aid flow (current US$) in Middle East & North Africa (developing only) in 2005 and the Aid flow (current US$) in Upper middle income in 2006?
Your answer should be compact. -3.13e+07. What is the difference between the Aid flow (current US$) of Middle East & North Africa (developing only) in 2005 and the Aid flow (current US$) of Mongolia in 2006?
Give a very brief answer. 3.72e+06. What is the difference between the Aid flow (current US$) of Middle East & North Africa (developing only) in 2005 and the Aid flow (current US$) of Myanmar in 2006?
Keep it short and to the point. 3.40e+06. What is the difference between the Aid flow (current US$) in Upper middle income in 2005 and the Aid flow (current US$) in Mongolia in 2006?
Provide a short and direct response. 4.23e+07. What is the difference between the Aid flow (current US$) in Upper middle income in 2005 and the Aid flow (current US$) in Myanmar in 2006?
Offer a very short reply. 4.20e+07. What is the difference between the Aid flow (current US$) in Mongolia in 2005 and the Aid flow (current US$) in Myanmar in 2006?
Ensure brevity in your answer.  -3.20e+05. What is the average Aid flow (current US$) in Middle East & North Africa (developing only) per year?
Make the answer very short. 3.18e+06. What is the average Aid flow (current US$) of Upper middle income per year?
Your answer should be compact. 2.73e+07. What is the average Aid flow (current US$) in Mongolia per year?
Provide a short and direct response. 3.52e+05. What is the average Aid flow (current US$) of Myanmar per year?
Give a very brief answer. 3.45e+05. In the year 1999, what is the difference between the Aid flow (current US$) of Middle East & North Africa (developing only) and Aid flow (current US$) of Upper middle income?
Provide a succinct answer. -2.32e+07. In the year 1999, what is the difference between the Aid flow (current US$) of Middle East & North Africa (developing only) and Aid flow (current US$) of Mongolia?
Give a very brief answer. -2.40e+05. In the year 1999, what is the difference between the Aid flow (current US$) in Middle East & North Africa (developing only) and Aid flow (current US$) in Myanmar?
Provide a short and direct response. 2.00e+04. In the year 1999, what is the difference between the Aid flow (current US$) in Upper middle income and Aid flow (current US$) in Mongolia?
Keep it short and to the point. 2.30e+07. In the year 1999, what is the difference between the Aid flow (current US$) of Upper middle income and Aid flow (current US$) of Myanmar?
Your answer should be compact. 2.32e+07. In the year 2000, what is the difference between the Aid flow (current US$) of Middle East & North Africa (developing only) and Aid flow (current US$) of Upper middle income?
Provide a succinct answer. -1.56e+07. In the year 2000, what is the difference between the Aid flow (current US$) of Middle East & North Africa (developing only) and Aid flow (current US$) of Mongolia?
Provide a succinct answer. -3.30e+05. In the year 2000, what is the difference between the Aid flow (current US$) in Upper middle income and Aid flow (current US$) in Mongolia?
Your response must be concise. 1.53e+07. In the year 2000, what is the difference between the Aid flow (current US$) of Upper middle income and Aid flow (current US$) of Myanmar?
Your answer should be very brief. 1.57e+07. In the year 2000, what is the difference between the Aid flow (current US$) in Mongolia and Aid flow (current US$) in Myanmar?
Ensure brevity in your answer.  3.90e+05. In the year 2001, what is the difference between the Aid flow (current US$) in Middle East & North Africa (developing only) and Aid flow (current US$) in Upper middle income?
Provide a short and direct response. -1.58e+07. In the year 2001, what is the difference between the Aid flow (current US$) in Middle East & North Africa (developing only) and Aid flow (current US$) in Myanmar?
Make the answer very short. 8.00e+04. In the year 2001, what is the difference between the Aid flow (current US$) of Upper middle income and Aid flow (current US$) of Mongolia?
Provide a succinct answer. 1.55e+07. In the year 2001, what is the difference between the Aid flow (current US$) of Upper middle income and Aid flow (current US$) of Myanmar?
Keep it short and to the point. 1.58e+07. In the year 2002, what is the difference between the Aid flow (current US$) in Middle East & North Africa (developing only) and Aid flow (current US$) in Upper middle income?
Ensure brevity in your answer.  -1.72e+07. In the year 2002, what is the difference between the Aid flow (current US$) of Middle East & North Africa (developing only) and Aid flow (current US$) of Mongolia?
Provide a short and direct response. 2.76e+06. In the year 2002, what is the difference between the Aid flow (current US$) of Middle East & North Africa (developing only) and Aid flow (current US$) of Myanmar?
Your answer should be compact. 3.09e+06. In the year 2002, what is the difference between the Aid flow (current US$) in Upper middle income and Aid flow (current US$) in Mongolia?
Make the answer very short. 2.00e+07. In the year 2002, what is the difference between the Aid flow (current US$) in Upper middle income and Aid flow (current US$) in Myanmar?
Provide a short and direct response. 2.03e+07. In the year 2003, what is the difference between the Aid flow (current US$) of Middle East & North Africa (developing only) and Aid flow (current US$) of Upper middle income?
Give a very brief answer. -2.47e+07. In the year 2003, what is the difference between the Aid flow (current US$) in Middle East & North Africa (developing only) and Aid flow (current US$) in Mongolia?
Make the answer very short. 1.00e+07. In the year 2003, what is the difference between the Aid flow (current US$) of Middle East & North Africa (developing only) and Aid flow (current US$) of Myanmar?
Provide a succinct answer. 9.87e+06. In the year 2003, what is the difference between the Aid flow (current US$) of Upper middle income and Aid flow (current US$) of Mongolia?
Offer a terse response. 3.48e+07. In the year 2003, what is the difference between the Aid flow (current US$) of Upper middle income and Aid flow (current US$) of Myanmar?
Ensure brevity in your answer.  3.46e+07. In the year 2003, what is the difference between the Aid flow (current US$) of Mongolia and Aid flow (current US$) of Myanmar?
Make the answer very short. -1.70e+05. In the year 2004, what is the difference between the Aid flow (current US$) in Middle East & North Africa (developing only) and Aid flow (current US$) in Upper middle income?
Offer a terse response. -2.62e+07. In the year 2004, what is the difference between the Aid flow (current US$) in Middle East & North Africa (developing only) and Aid flow (current US$) in Mongolia?
Your response must be concise. 3.13e+06. In the year 2004, what is the difference between the Aid flow (current US$) in Middle East & North Africa (developing only) and Aid flow (current US$) in Myanmar?
Your response must be concise. 2.79e+06. In the year 2004, what is the difference between the Aid flow (current US$) of Upper middle income and Aid flow (current US$) of Mongolia?
Offer a terse response. 2.93e+07. In the year 2004, what is the difference between the Aid flow (current US$) of Upper middle income and Aid flow (current US$) of Myanmar?
Offer a terse response. 2.90e+07. In the year 2005, what is the difference between the Aid flow (current US$) of Middle East & North Africa (developing only) and Aid flow (current US$) of Upper middle income?
Provide a short and direct response. -3.86e+07. In the year 2005, what is the difference between the Aid flow (current US$) of Middle East & North Africa (developing only) and Aid flow (current US$) of Mongolia?
Offer a very short reply. 3.72e+06. In the year 2005, what is the difference between the Aid flow (current US$) in Middle East & North Africa (developing only) and Aid flow (current US$) in Myanmar?
Provide a short and direct response. 3.30e+06. In the year 2005, what is the difference between the Aid flow (current US$) of Upper middle income and Aid flow (current US$) of Mongolia?
Give a very brief answer. 4.23e+07. In the year 2005, what is the difference between the Aid flow (current US$) in Upper middle income and Aid flow (current US$) in Myanmar?
Make the answer very short. 4.19e+07. In the year 2005, what is the difference between the Aid flow (current US$) in Mongolia and Aid flow (current US$) in Myanmar?
Your answer should be compact. -4.20e+05. In the year 2006, what is the difference between the Aid flow (current US$) in Middle East & North Africa (developing only) and Aid flow (current US$) in Upper middle income?
Provide a short and direct response. -3.13e+07. In the year 2006, what is the difference between the Aid flow (current US$) in Middle East & North Africa (developing only) and Aid flow (current US$) in Mongolia?
Your answer should be very brief. 3.78e+06. In the year 2006, what is the difference between the Aid flow (current US$) in Middle East & North Africa (developing only) and Aid flow (current US$) in Myanmar?
Ensure brevity in your answer.  3.46e+06. In the year 2006, what is the difference between the Aid flow (current US$) of Upper middle income and Aid flow (current US$) of Mongolia?
Your response must be concise. 3.50e+07. In the year 2006, what is the difference between the Aid flow (current US$) of Upper middle income and Aid flow (current US$) of Myanmar?
Your response must be concise. 3.47e+07. In the year 2006, what is the difference between the Aid flow (current US$) in Mongolia and Aid flow (current US$) in Myanmar?
Give a very brief answer. -3.20e+05. What is the ratio of the Aid flow (current US$) in Middle East & North Africa (developing only) in 1999 to that in 2000?
Provide a succinct answer. 0.81. What is the ratio of the Aid flow (current US$) in Upper middle income in 1999 to that in 2000?
Your response must be concise. 1.48. What is the ratio of the Aid flow (current US$) of Mongolia in 1999 to that in 2000?
Your response must be concise. 0.76. What is the ratio of the Aid flow (current US$) of Middle East & North Africa (developing only) in 1999 to that in 2001?
Provide a succinct answer. 0.87. What is the ratio of the Aid flow (current US$) in Upper middle income in 1999 to that in 2001?
Your response must be concise. 1.47. What is the ratio of the Aid flow (current US$) in Mongolia in 1999 to that in 2001?
Offer a terse response. 0.93. What is the ratio of the Aid flow (current US$) in Myanmar in 1999 to that in 2001?
Offer a terse response. 1.57. What is the ratio of the Aid flow (current US$) in Middle East & North Africa (developing only) in 1999 to that in 2002?
Provide a succinct answer. 0.04. What is the ratio of the Aid flow (current US$) of Upper middle income in 1999 to that in 2002?
Offer a terse response. 1.15. What is the ratio of the Aid flow (current US$) of Mongolia in 1999 to that in 2002?
Keep it short and to the point. 0.93. What is the ratio of the Aid flow (current US$) of Myanmar in 1999 to that in 2002?
Offer a terse response. 1.57. What is the ratio of the Aid flow (current US$) in Middle East & North Africa (developing only) in 1999 to that in 2003?
Keep it short and to the point. 0.01. What is the ratio of the Aid flow (current US$) of Mongolia in 1999 to that in 2003?
Your answer should be very brief. 1.48. What is the ratio of the Aid flow (current US$) in Myanmar in 1999 to that in 2003?
Provide a succinct answer. 0.26. What is the ratio of the Aid flow (current US$) in Middle East & North Africa (developing only) in 1999 to that in 2004?
Offer a terse response. 0.04. What is the ratio of the Aid flow (current US$) of Upper middle income in 1999 to that in 2004?
Provide a succinct answer. 0.79. What is the ratio of the Aid flow (current US$) in Mongolia in 1999 to that in 2004?
Offer a very short reply. 1.48. What is the ratio of the Aid flow (current US$) of Myanmar in 1999 to that in 2004?
Provide a succinct answer. 0.19. What is the ratio of the Aid flow (current US$) of Middle East & North Africa (developing only) in 1999 to that in 2005?
Provide a succinct answer. 0.03. What is the ratio of the Aid flow (current US$) in Upper middle income in 1999 to that in 2005?
Offer a terse response. 0.55. What is the ratio of the Aid flow (current US$) of Mongolia in 1999 to that in 2005?
Offer a terse response. 1.12. What is the ratio of the Aid flow (current US$) of Myanmar in 1999 to that in 2005?
Offer a terse response. 0.15. What is the ratio of the Aid flow (current US$) in Middle East & North Africa (developing only) in 1999 to that in 2006?
Keep it short and to the point. 0.03. What is the ratio of the Aid flow (current US$) of Upper middle income in 1999 to that in 2006?
Keep it short and to the point. 0.66. What is the ratio of the Aid flow (current US$) of Mongolia in 1999 to that in 2006?
Keep it short and to the point. 1.12. What is the ratio of the Aid flow (current US$) in Myanmar in 1999 to that in 2006?
Provide a succinct answer. 0.17. What is the ratio of the Aid flow (current US$) of Middle East & North Africa (developing only) in 2000 to that in 2001?
Ensure brevity in your answer.  1.07. What is the ratio of the Aid flow (current US$) of Mongolia in 2000 to that in 2001?
Ensure brevity in your answer.  1.23. What is the ratio of the Aid flow (current US$) in Myanmar in 2000 to that in 2001?
Make the answer very short. 1.43. What is the ratio of the Aid flow (current US$) of Middle East & North Africa (developing only) in 2000 to that in 2002?
Your answer should be very brief. 0.05. What is the ratio of the Aid flow (current US$) in Upper middle income in 2000 to that in 2002?
Provide a succinct answer. 0.78. What is the ratio of the Aid flow (current US$) of Mongolia in 2000 to that in 2002?
Offer a very short reply. 1.23. What is the ratio of the Aid flow (current US$) in Myanmar in 2000 to that in 2002?
Offer a very short reply. 1.43. What is the ratio of the Aid flow (current US$) of Middle East & North Africa (developing only) in 2000 to that in 2003?
Ensure brevity in your answer.  0.02. What is the ratio of the Aid flow (current US$) in Upper middle income in 2000 to that in 2003?
Keep it short and to the point. 0.45. What is the ratio of the Aid flow (current US$) in Mongolia in 2000 to that in 2003?
Your answer should be very brief. 1.96. What is the ratio of the Aid flow (current US$) of Myanmar in 2000 to that in 2003?
Your answer should be very brief. 0.24. What is the ratio of the Aid flow (current US$) in Middle East & North Africa (developing only) in 2000 to that in 2004?
Provide a succinct answer. 0.05. What is the ratio of the Aid flow (current US$) of Upper middle income in 2000 to that in 2004?
Ensure brevity in your answer.  0.53. What is the ratio of the Aid flow (current US$) of Mongolia in 2000 to that in 2004?
Make the answer very short. 1.96. What is the ratio of the Aid flow (current US$) of Myanmar in 2000 to that in 2004?
Make the answer very short. 0.17. What is the ratio of the Aid flow (current US$) in Middle East & North Africa (developing only) in 2000 to that in 2005?
Keep it short and to the point. 0.04. What is the ratio of the Aid flow (current US$) of Upper middle income in 2000 to that in 2005?
Keep it short and to the point. 0.37. What is the ratio of the Aid flow (current US$) of Mongolia in 2000 to that in 2005?
Ensure brevity in your answer.  1.48. What is the ratio of the Aid flow (current US$) in Myanmar in 2000 to that in 2005?
Ensure brevity in your answer.  0.13. What is the ratio of the Aid flow (current US$) of Middle East & North Africa (developing only) in 2000 to that in 2006?
Ensure brevity in your answer.  0.04. What is the ratio of the Aid flow (current US$) of Upper middle income in 2000 to that in 2006?
Your answer should be very brief. 0.45. What is the ratio of the Aid flow (current US$) of Mongolia in 2000 to that in 2006?
Provide a succinct answer. 1.48. What is the ratio of the Aid flow (current US$) in Myanmar in 2000 to that in 2006?
Give a very brief answer. 0.15. What is the ratio of the Aid flow (current US$) of Middle East & North Africa (developing only) in 2001 to that in 2002?
Provide a short and direct response. 0.05. What is the ratio of the Aid flow (current US$) in Upper middle income in 2001 to that in 2002?
Ensure brevity in your answer.  0.78. What is the ratio of the Aid flow (current US$) of Mongolia in 2001 to that in 2002?
Provide a short and direct response. 1. What is the ratio of the Aid flow (current US$) of Middle East & North Africa (developing only) in 2001 to that in 2003?
Offer a terse response. 0.01. What is the ratio of the Aid flow (current US$) in Upper middle income in 2001 to that in 2003?
Your response must be concise. 0.45. What is the ratio of the Aid flow (current US$) in Myanmar in 2001 to that in 2003?
Your answer should be very brief. 0.17. What is the ratio of the Aid flow (current US$) in Middle East & North Africa (developing only) in 2001 to that in 2004?
Your answer should be very brief. 0.04. What is the ratio of the Aid flow (current US$) of Upper middle income in 2001 to that in 2004?
Your response must be concise. 0.54. What is the ratio of the Aid flow (current US$) in Mongolia in 2001 to that in 2004?
Your answer should be very brief. 1.6. What is the ratio of the Aid flow (current US$) of Myanmar in 2001 to that in 2004?
Your answer should be compact. 0.12. What is the ratio of the Aid flow (current US$) of Middle East & North Africa (developing only) in 2001 to that in 2005?
Offer a very short reply. 0.04. What is the ratio of the Aid flow (current US$) in Upper middle income in 2001 to that in 2005?
Keep it short and to the point. 0.37. What is the ratio of the Aid flow (current US$) of Mongolia in 2001 to that in 2005?
Your response must be concise. 1.21. What is the ratio of the Aid flow (current US$) of Myanmar in 2001 to that in 2005?
Your response must be concise. 0.09. What is the ratio of the Aid flow (current US$) in Middle East & North Africa (developing only) in 2001 to that in 2006?
Offer a very short reply. 0.04. What is the ratio of the Aid flow (current US$) of Upper middle income in 2001 to that in 2006?
Your response must be concise. 0.45. What is the ratio of the Aid flow (current US$) of Mongolia in 2001 to that in 2006?
Provide a short and direct response. 1.21. What is the ratio of the Aid flow (current US$) of Myanmar in 2001 to that in 2006?
Your response must be concise. 0.11. What is the ratio of the Aid flow (current US$) in Middle East & North Africa (developing only) in 2002 to that in 2003?
Keep it short and to the point. 0.31. What is the ratio of the Aid flow (current US$) of Upper middle income in 2002 to that in 2003?
Make the answer very short. 0.58. What is the ratio of the Aid flow (current US$) of Middle East & North Africa (developing only) in 2002 to that in 2004?
Keep it short and to the point. 0.93. What is the ratio of the Aid flow (current US$) of Upper middle income in 2002 to that in 2004?
Your answer should be very brief. 0.69. What is the ratio of the Aid flow (current US$) of Mongolia in 2002 to that in 2004?
Provide a short and direct response. 1.6. What is the ratio of the Aid flow (current US$) in Myanmar in 2002 to that in 2004?
Provide a succinct answer. 0.12. What is the ratio of the Aid flow (current US$) of Middle East & North Africa (developing only) in 2002 to that in 2005?
Ensure brevity in your answer.  0.78. What is the ratio of the Aid flow (current US$) of Upper middle income in 2002 to that in 2005?
Keep it short and to the point. 0.48. What is the ratio of the Aid flow (current US$) of Mongolia in 2002 to that in 2005?
Ensure brevity in your answer.  1.21. What is the ratio of the Aid flow (current US$) of Myanmar in 2002 to that in 2005?
Ensure brevity in your answer.  0.09. What is the ratio of the Aid flow (current US$) of Middle East & North Africa (developing only) in 2002 to that in 2006?
Your answer should be very brief. 0.77. What is the ratio of the Aid flow (current US$) of Upper middle income in 2002 to that in 2006?
Your answer should be compact. 0.58. What is the ratio of the Aid flow (current US$) in Mongolia in 2002 to that in 2006?
Your answer should be very brief. 1.21. What is the ratio of the Aid flow (current US$) of Myanmar in 2002 to that in 2006?
Your answer should be very brief. 0.11. What is the ratio of the Aid flow (current US$) in Middle East & North Africa (developing only) in 2003 to that in 2004?
Your response must be concise. 3.04. What is the ratio of the Aid flow (current US$) of Upper middle income in 2003 to that in 2004?
Make the answer very short. 1.18. What is the ratio of the Aid flow (current US$) of Mongolia in 2003 to that in 2004?
Provide a short and direct response. 1. What is the ratio of the Aid flow (current US$) of Myanmar in 2003 to that in 2004?
Your answer should be very brief. 0.71. What is the ratio of the Aid flow (current US$) in Middle East & North Africa (developing only) in 2003 to that in 2005?
Provide a short and direct response. 2.54. What is the ratio of the Aid flow (current US$) in Upper middle income in 2003 to that in 2005?
Offer a terse response. 0.82. What is the ratio of the Aid flow (current US$) in Mongolia in 2003 to that in 2005?
Keep it short and to the point. 0.76. What is the ratio of the Aid flow (current US$) of Myanmar in 2003 to that in 2005?
Offer a terse response. 0.56. What is the ratio of the Aid flow (current US$) of Middle East & North Africa (developing only) in 2003 to that in 2006?
Make the answer very short. 2.5. What is the ratio of the Aid flow (current US$) of Mongolia in 2003 to that in 2006?
Your response must be concise. 0.76. What is the ratio of the Aid flow (current US$) of Myanmar in 2003 to that in 2006?
Keep it short and to the point. 0.65. What is the ratio of the Aid flow (current US$) in Middle East & North Africa (developing only) in 2004 to that in 2005?
Make the answer very short. 0.83. What is the ratio of the Aid flow (current US$) of Upper middle income in 2004 to that in 2005?
Ensure brevity in your answer.  0.69. What is the ratio of the Aid flow (current US$) of Mongolia in 2004 to that in 2005?
Give a very brief answer. 0.76. What is the ratio of the Aid flow (current US$) in Myanmar in 2004 to that in 2005?
Offer a very short reply. 0.79. What is the ratio of the Aid flow (current US$) in Middle East & North Africa (developing only) in 2004 to that in 2006?
Provide a succinct answer. 0.82. What is the ratio of the Aid flow (current US$) of Upper middle income in 2004 to that in 2006?
Provide a short and direct response. 0.84. What is the ratio of the Aid flow (current US$) in Mongolia in 2004 to that in 2006?
Keep it short and to the point. 0.76. What is the ratio of the Aid flow (current US$) of Myanmar in 2004 to that in 2006?
Give a very brief answer. 0.91. What is the ratio of the Aid flow (current US$) of Middle East & North Africa (developing only) in 2005 to that in 2006?
Keep it short and to the point. 0.99. What is the ratio of the Aid flow (current US$) of Upper middle income in 2005 to that in 2006?
Give a very brief answer. 1.21. What is the ratio of the Aid flow (current US$) in Mongolia in 2005 to that in 2006?
Provide a succinct answer. 1. What is the ratio of the Aid flow (current US$) in Myanmar in 2005 to that in 2006?
Ensure brevity in your answer.  1.15. What is the difference between the highest and the second highest Aid flow (current US$) in Middle East & North Africa (developing only)?
Ensure brevity in your answer.  6.18e+06. What is the difference between the highest and the second highest Aid flow (current US$) of Upper middle income?
Offer a terse response. 7.28e+06. What is the difference between the highest and the second highest Aid flow (current US$) in Mongolia?
Provide a succinct answer. 9.00e+04. What is the difference between the highest and the lowest Aid flow (current US$) in Middle East & North Africa (developing only)?
Provide a succinct answer. 1.02e+07. What is the difference between the highest and the lowest Aid flow (current US$) of Upper middle income?
Offer a terse response. 2.68e+07. What is the difference between the highest and the lowest Aid flow (current US$) of Myanmar?
Ensure brevity in your answer.  6.80e+05. 